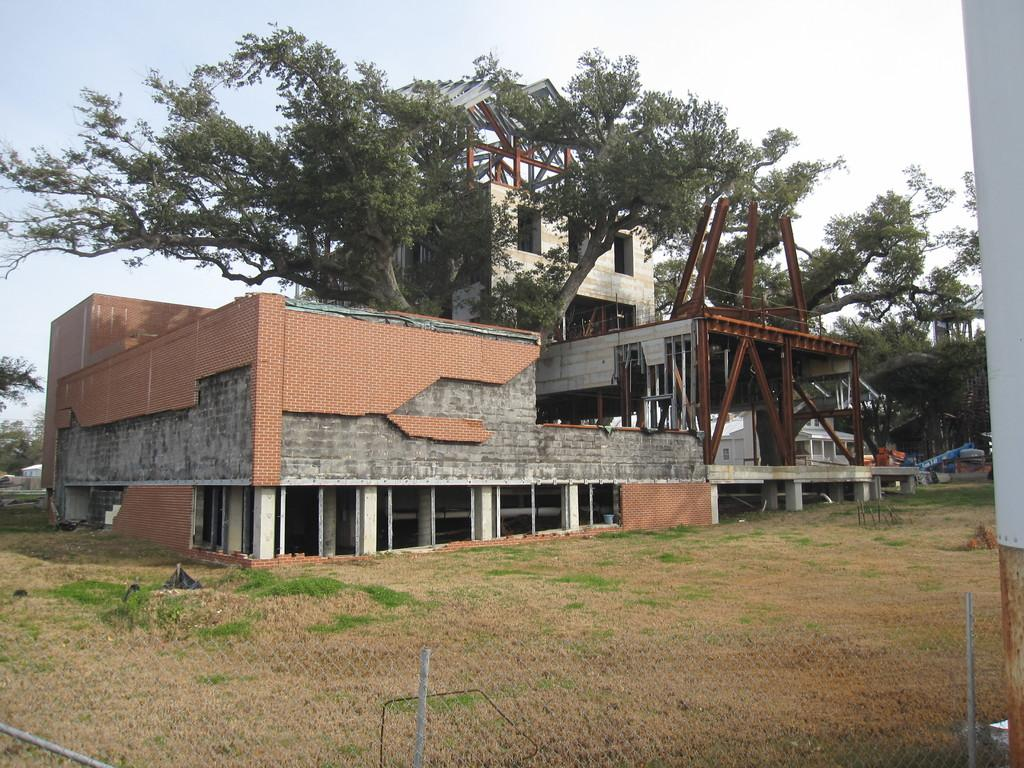What is the main subject of the image? The main subject of the image is a building under construction. What can be seen between the buildings in the image? There are trees between the buildings in the image. What type of vegetation is in front of the building? There is grass in front of the building. What is used to enclose the construction site? There is fencing around the building. How many toes can be seen on the sheep in the image? There are no sheep present in the image, and therefore no toes can be seen. 